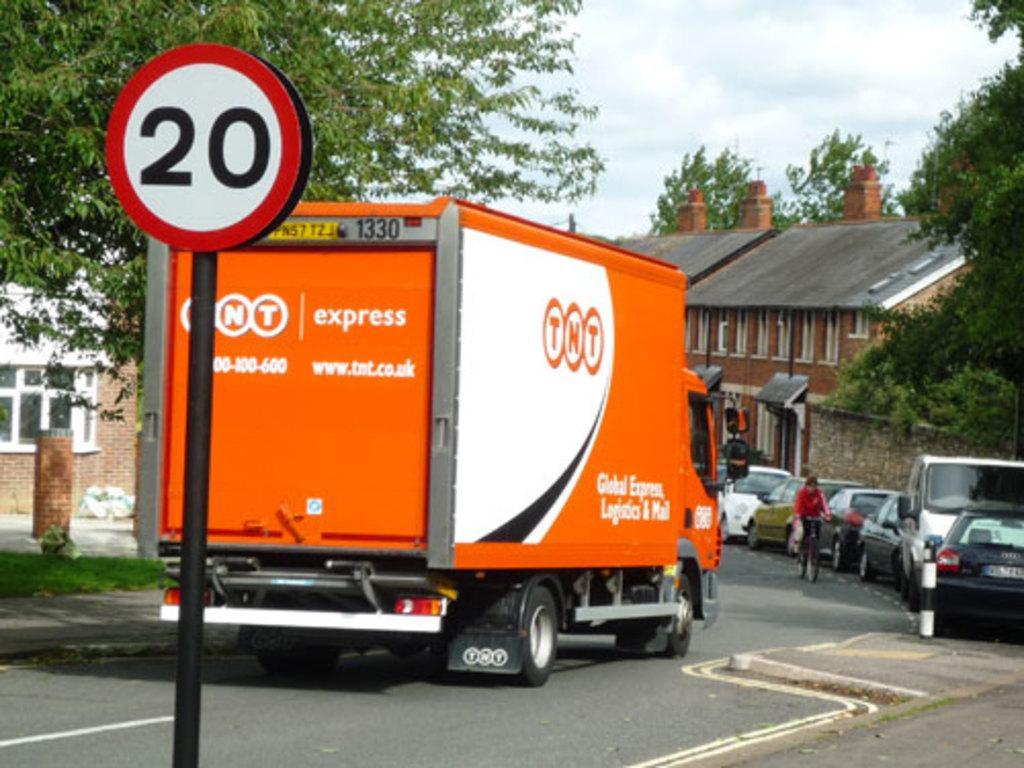How would you summarize this image in a sentence or two? In this picture there is a van in the center of the image, there is a sign pole on the left side of the image, there are cars and houses on the right side of the image and there are trees on the right and left side of the image. 